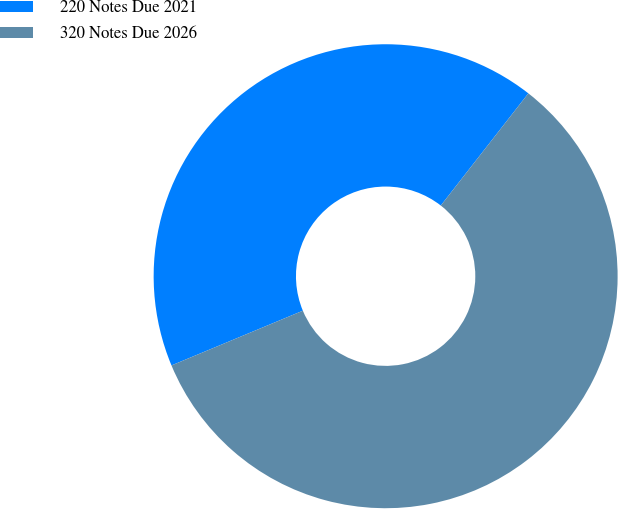Convert chart to OTSL. <chart><loc_0><loc_0><loc_500><loc_500><pie_chart><fcel>220 Notes Due 2021<fcel>320 Notes Due 2026<nl><fcel>41.83%<fcel>58.17%<nl></chart> 